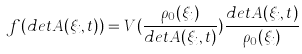Convert formula to latex. <formula><loc_0><loc_0><loc_500><loc_500>f ( d e t A ( \xi _ { i } , t ) ) = V ( \frac { \rho _ { 0 } ( \xi _ { i } ) } { d e t A ( \xi _ { i } , t ) } ) \frac { d e t A ( \xi _ { i } , t ) } { \rho _ { 0 } ( \xi _ { i } ) }</formula> 